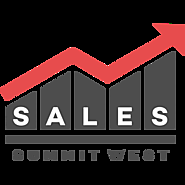Could you tell me more about the choice of colors in this logo? Certainly, the logo uses a minimalistic color palette consisting of black, red, and white, each serving a specific purpose. Black provides a strong foundation, denoting seriousness and professionalism, which is apt for a business summit. Red is used selectively for the upward arrow in the graph, which cleverly denotes growth, energy, and passion, qualities that are often associated with successful sales strategies. The white background ensures that these elements stand out clearly, which is crucial for quick recognition and effective branding. 